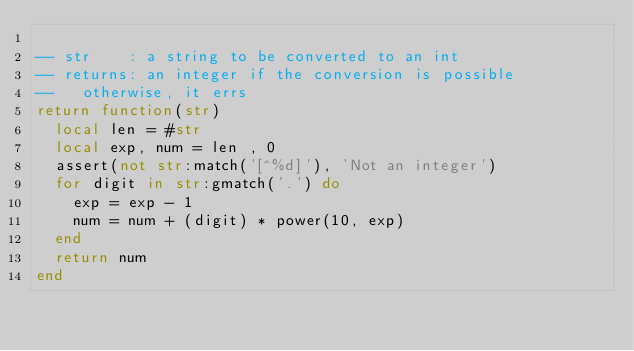<code> <loc_0><loc_0><loc_500><loc_500><_Lua_>
-- str    : a string to be converted to an int
-- returns: an integer if the conversion is possible
--   otherwise, it errs
return function(str)
  local len = #str
  local exp, num = len , 0
  assert(not str:match('[^%d]'), 'Not an integer')
  for digit in str:gmatch('.') do
    exp = exp - 1
    num = num + (digit) * power(10, exp)
  end
  return num
end
</code> 